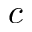<formula> <loc_0><loc_0><loc_500><loc_500>c</formula> 